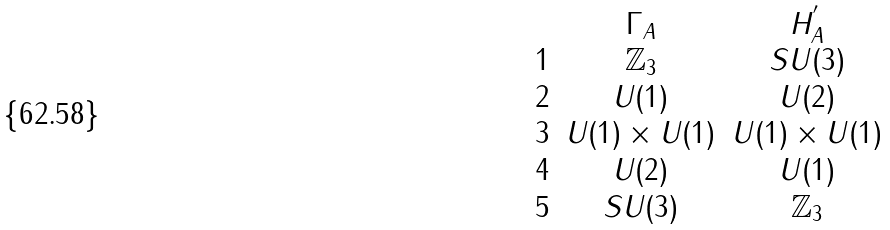<formula> <loc_0><loc_0><loc_500><loc_500>\begin{array} { c c c } & \Gamma _ { A } & H _ { A } ^ { ^ { \prime } } \\ 1 & \mathbb { Z } _ { 3 } & S U ( 3 ) \\ 2 & U ( 1 ) & U ( 2 ) \\ 3 & U ( 1 ) \times U ( 1 ) & U ( 1 ) \times U ( 1 ) \\ 4 & U ( 2 ) & U ( 1 ) \\ 5 & S U ( 3 ) & \mathbb { Z } _ { 3 } \end{array}</formula> 